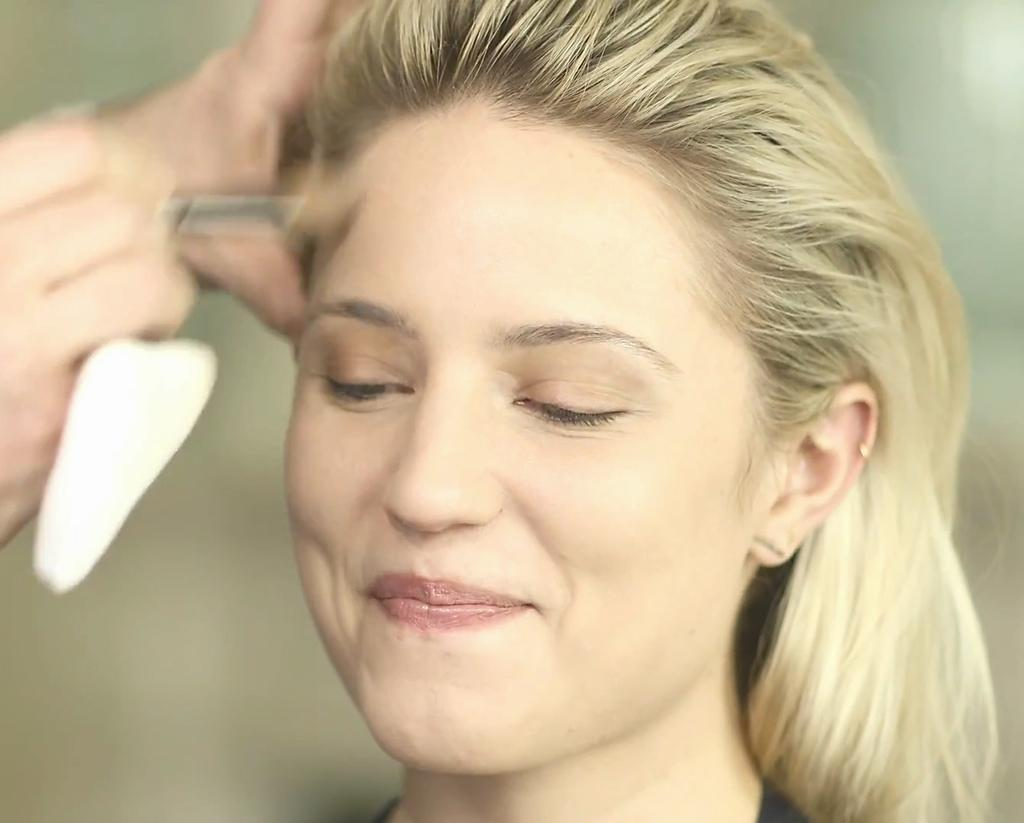Who is present in the image? There is a woman in the image. What is the woman's expression? The woman is smiling. What can be seen in the woman's hand? There is a person's hand holding something in the image, but the object is blurred. Can you describe the background of the image? The background of the image is blurred and plain. How many cows are visible in the image? There are no cows present in the image. What time of day is it in the image, considering the night theme? The image does not have a night theme, and the time of day cannot be determined from the information provided. 